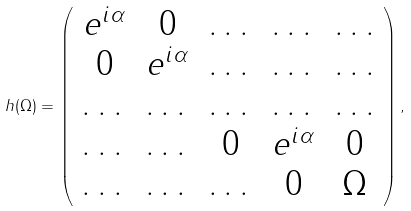<formula> <loc_0><loc_0><loc_500><loc_500>h ( \Omega ) = \left ( \begin{array} { c c c c c } e ^ { i \alpha } & 0 & \dots & \dots & \dots \\ 0 & e ^ { i \alpha } & \dots & \dots & \dots \\ \dots & \dots & \dots & \dots & \dots \\ \dots & \dots & 0 & e ^ { i \alpha } & 0 \\ \dots & \dots & \dots & 0 & \Omega \end{array} \right ) ,</formula> 